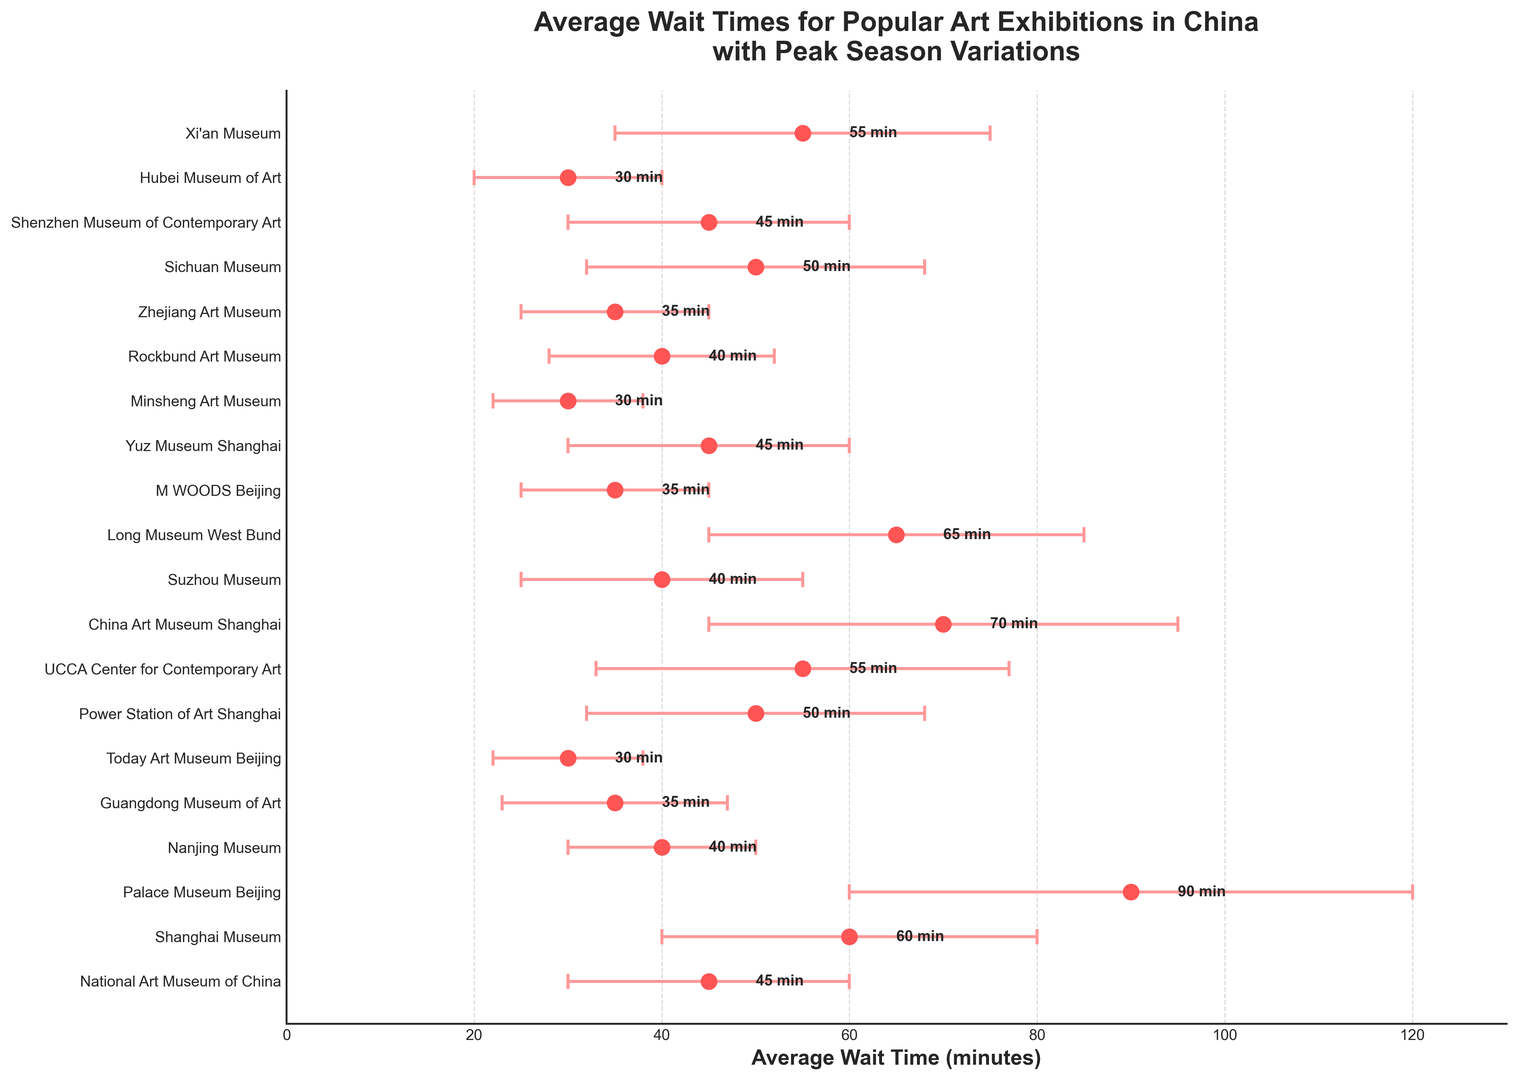What's the shortest average wait time for an art exhibition? By looking at the x-axis values, the Today Art Museum Beijing and Minsheng Art Museum have the shortest average wait times of 30 minutes each.
Answer: 30 minutes Which art exhibition has the longest peak season variation in wait times? The Palace Museum Beijing has the longest peak season variation, which can be determined by looking at the largest horizontal error bar, which is 30 minutes.
Answer: Palace Museum Beijing How do the average wait times for Shanghai Museum and Palace Museum Beijing compare? The Shanghai Museum has an average wait time of 60 minutes, while the Palace Museum Beijing has 90 minutes. Comparing these, we see the Palace Museum Beijing has a longer wait time.
Answer: Palace Museum Beijing has a longer wait time What's the sum of average wait times for the National Art Museum of China and the Power Station of Art Shanghai? The National Art Museum of China has an average wait time of 45 minutes and the Power Station of Art Shanghai has 50 minutes. Adding these together gives 45 + 50 = 95.
Answer: 95 minutes What's the average peak season variation for the National Art Museum of China, Guangdong Museum of Art, and Hubei Museum of Art? The peak season variations for the National Art Museum of China, Guangdong Museum of Art, and Hubei Museum of Art are 15, 12, and 10 minutes respectively. Adding them up (15 + 12 + 10) gives 37, and the average is 37/3 = 12.3 minutes.
Answer: 12.3 minutes Which has a higher wait time, M WOODS Beijing or Shenzhen Museum of Contemporary Art? M WOODS Beijing has an average wait time of 35 minutes while the Shenzhen Museum of Contemporary Art has 45 minutes. Therefore, the Shenzhen Museum of Contemporary Art has a higher wait time.
Answer: Shenzhen Museum of Contemporary Art Which art exhibitions have the same average wait time of 40 minutes? By looking at the x-axis values, Nanjing Museum, Suzhou Museum, and Rockbund Art Museum each have an average wait time of 40 minutes.
Answer: Nanjing Museum, Suzhou Museum, Rockbund Art Museum What is the total peak season variation for the exhibitions in Shanghai? The Shanghai-based exhibitions are Shanghai Museum (20 minutes), Power Station of Art Shanghai (18 minutes), China Art Museum Shanghai (25 minutes), and Yuz Museum Shanghai (15 minutes). Adding these 20 + 18 + 25 + 15 gives 78 minutes.
Answer: 78 minutes How does the average wait time of Sichuan Museum compare to the UCCA Center for Contemporary Art? The average wait time for Sichuan Museum is 50 minutes and for the UCCA Center for Contemporary Art, it is 55 minutes. Thus, the UCCA Center for Contemporary Art has a longer average wait time than Sichuan Museum.
Answer: UCCA Center for Contemporary Art has a longer wait time 